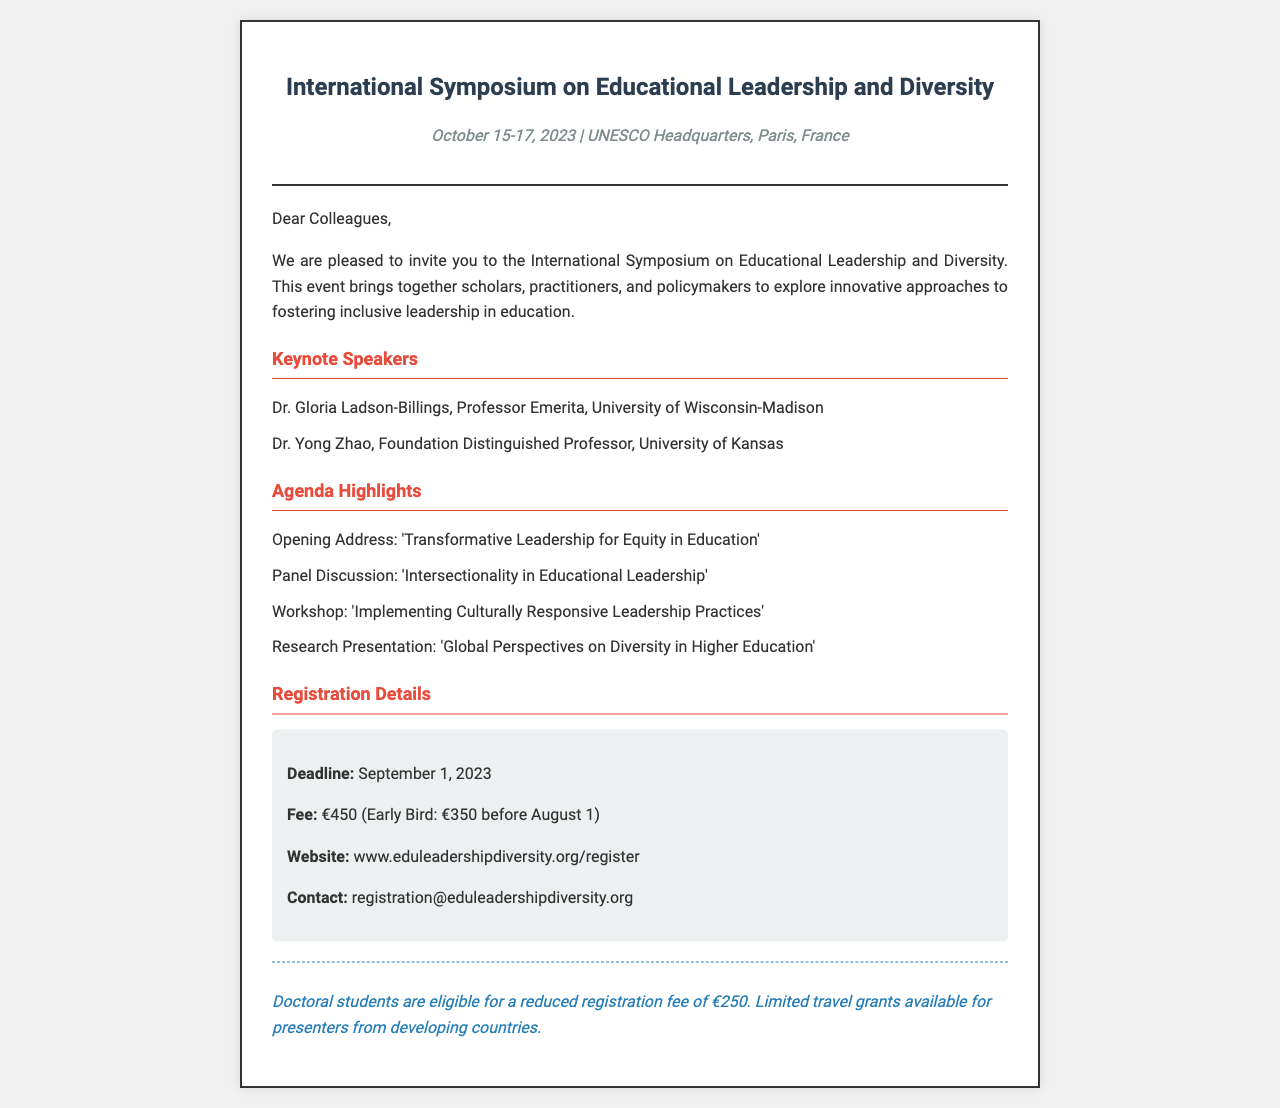What are the dates of the symposium? The symposium is scheduled to take place from October 15 to 17, 2023.
Answer: October 15-17, 2023 Who is one of the keynote speakers? The document lists Dr. Gloria Ladson-Billings and Dr. Yong Zhao as keynote speakers.
Answer: Dr. Gloria Ladson-Billings What is the early bird registration fee? The early bird registration fee is mentioned as €350 for registration before August 1.
Answer: €350 What type of event is this document inviting participants to? The invitation is for an International Symposium on Educational Leadership and Diversity.
Answer: International Symposium Is there a special fee for doctoral students? The document states that doctoral students have a different registration fee, indicating eligibility for a reduced rate.
Answer: Yes What is the deadline for registration? The registration deadline is specified in the document as September 1, 2023.
Answer: September 1, 2023 Where is the symposium taking place? The venue of the symposium is UNESCO Headquarters in Paris, France.
Answer: UNESCO Headquarters, Paris, France What is one of the agenda highlights? The document outlines several agenda highlights, one of which is related to transformative leadership.
Answer: Transformative Leadership for Equity in Education 